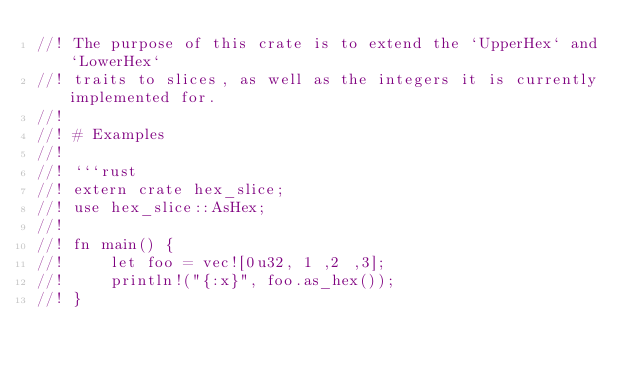<code> <loc_0><loc_0><loc_500><loc_500><_Rust_>//! The purpose of this crate is to extend the `UpperHex` and `LowerHex`
//! traits to slices, as well as the integers it is currently implemented for.
//!
//! # Examples
//!
//! ```rust
//! extern crate hex_slice;
//! use hex_slice::AsHex;
//!
//! fn main() {
//!     let foo = vec![0u32, 1 ,2 ,3];
//!     println!("{:x}", foo.as_hex());
//! }</code> 